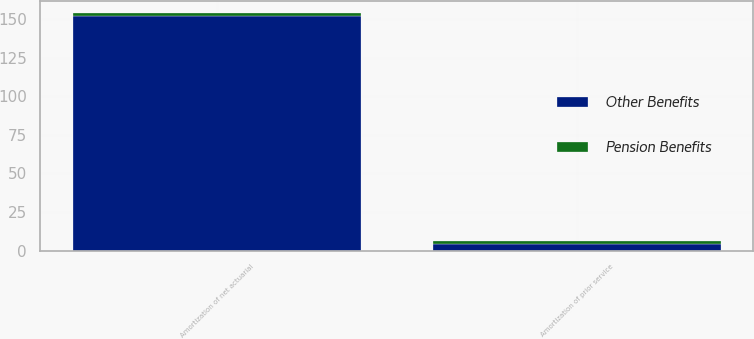<chart> <loc_0><loc_0><loc_500><loc_500><stacked_bar_chart><ecel><fcel>Amortization of prior service<fcel>Amortization of net actuarial<nl><fcel>Other Benefits<fcel>4<fcel>152<nl><fcel>Pension Benefits<fcel>2<fcel>2<nl></chart> 